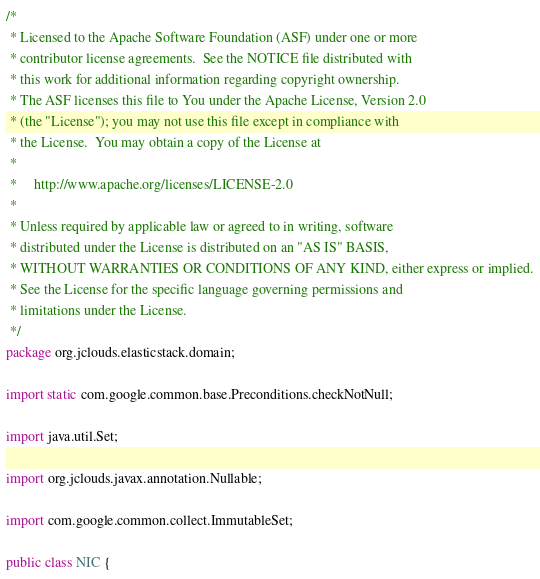<code> <loc_0><loc_0><loc_500><loc_500><_Java_>/*
 * Licensed to the Apache Software Foundation (ASF) under one or more
 * contributor license agreements.  See the NOTICE file distributed with
 * this work for additional information regarding copyright ownership.
 * The ASF licenses this file to You under the Apache License, Version 2.0
 * (the "License"); you may not use this file except in compliance with
 * the License.  You may obtain a copy of the License at
 *
 *     http://www.apache.org/licenses/LICENSE-2.0
 *
 * Unless required by applicable law or agreed to in writing, software
 * distributed under the License is distributed on an "AS IS" BASIS,
 * WITHOUT WARRANTIES OR CONDITIONS OF ANY KIND, either express or implied.
 * See the License for the specific language governing permissions and
 * limitations under the License.
 */
package org.jclouds.elasticstack.domain;

import static com.google.common.base.Preconditions.checkNotNull;

import java.util.Set;

import org.jclouds.javax.annotation.Nullable;

import com.google.common.collect.ImmutableSet;

public class NIC {</code> 